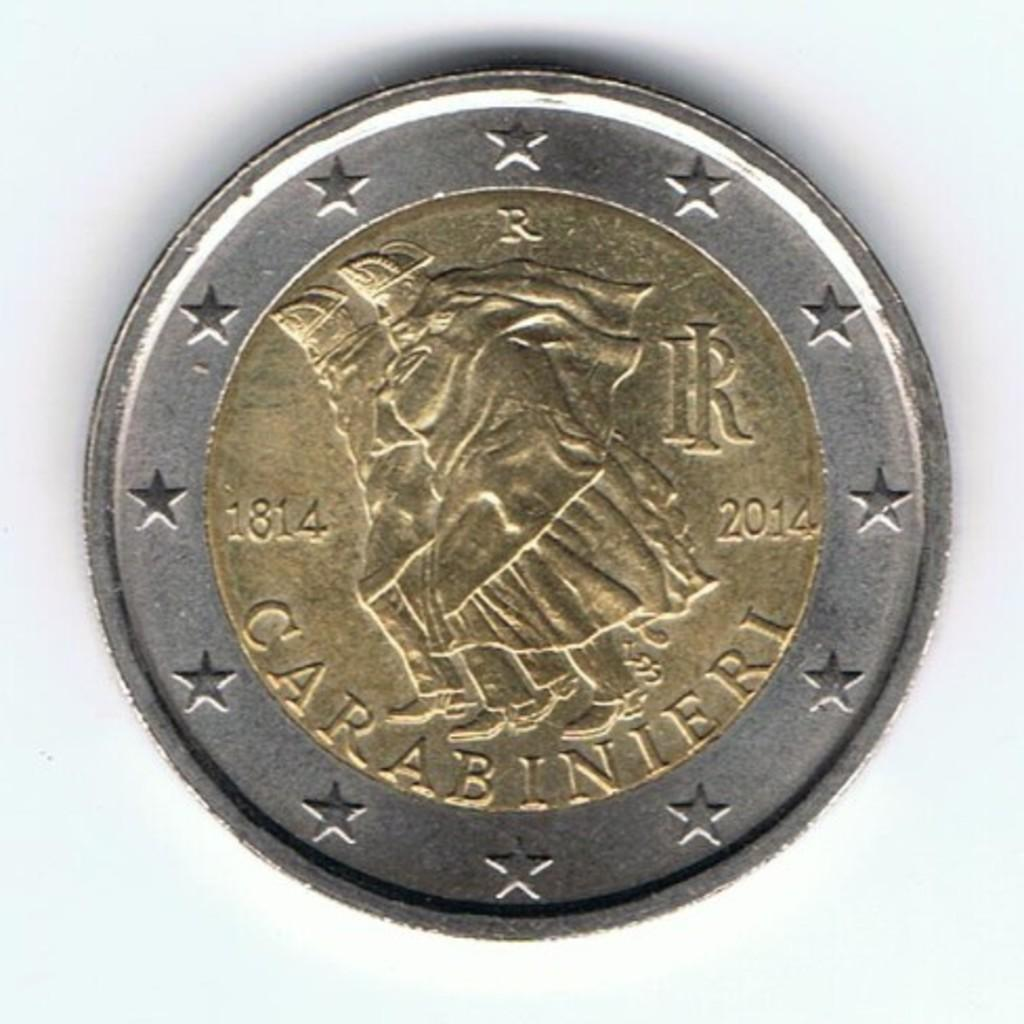<image>
Offer a succinct explanation of the picture presented. a coin dated 1814 and 2014 that says CARABINIERI on it. 